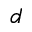Convert formula to latex. <formula><loc_0><loc_0><loc_500><loc_500>d</formula> 